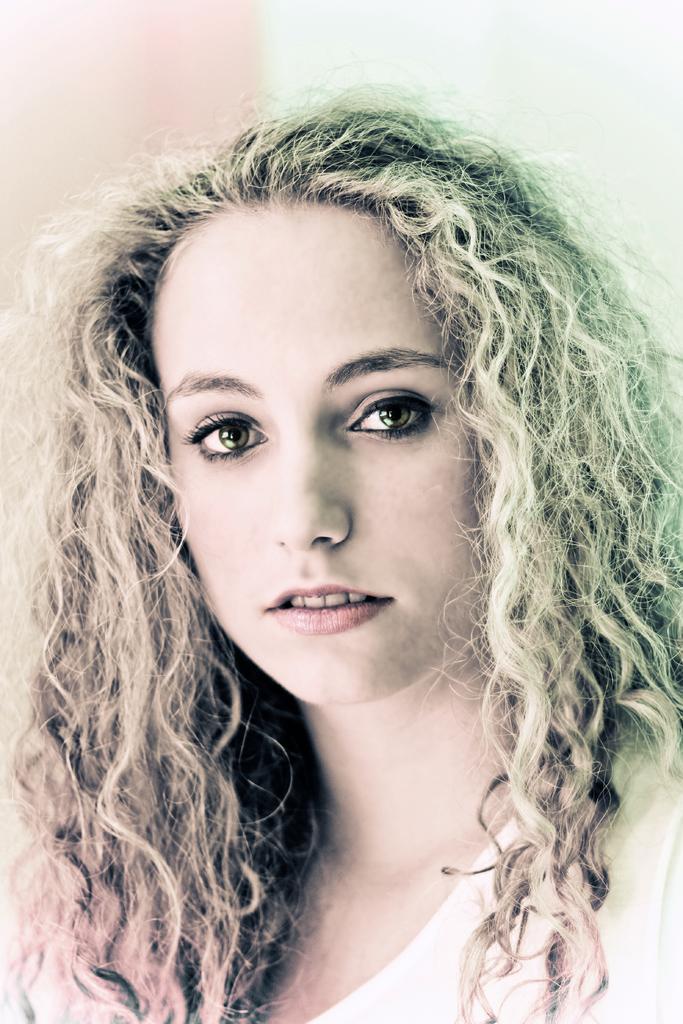Please provide a concise description of this image. In this picture there is a girl in the center of the image. 